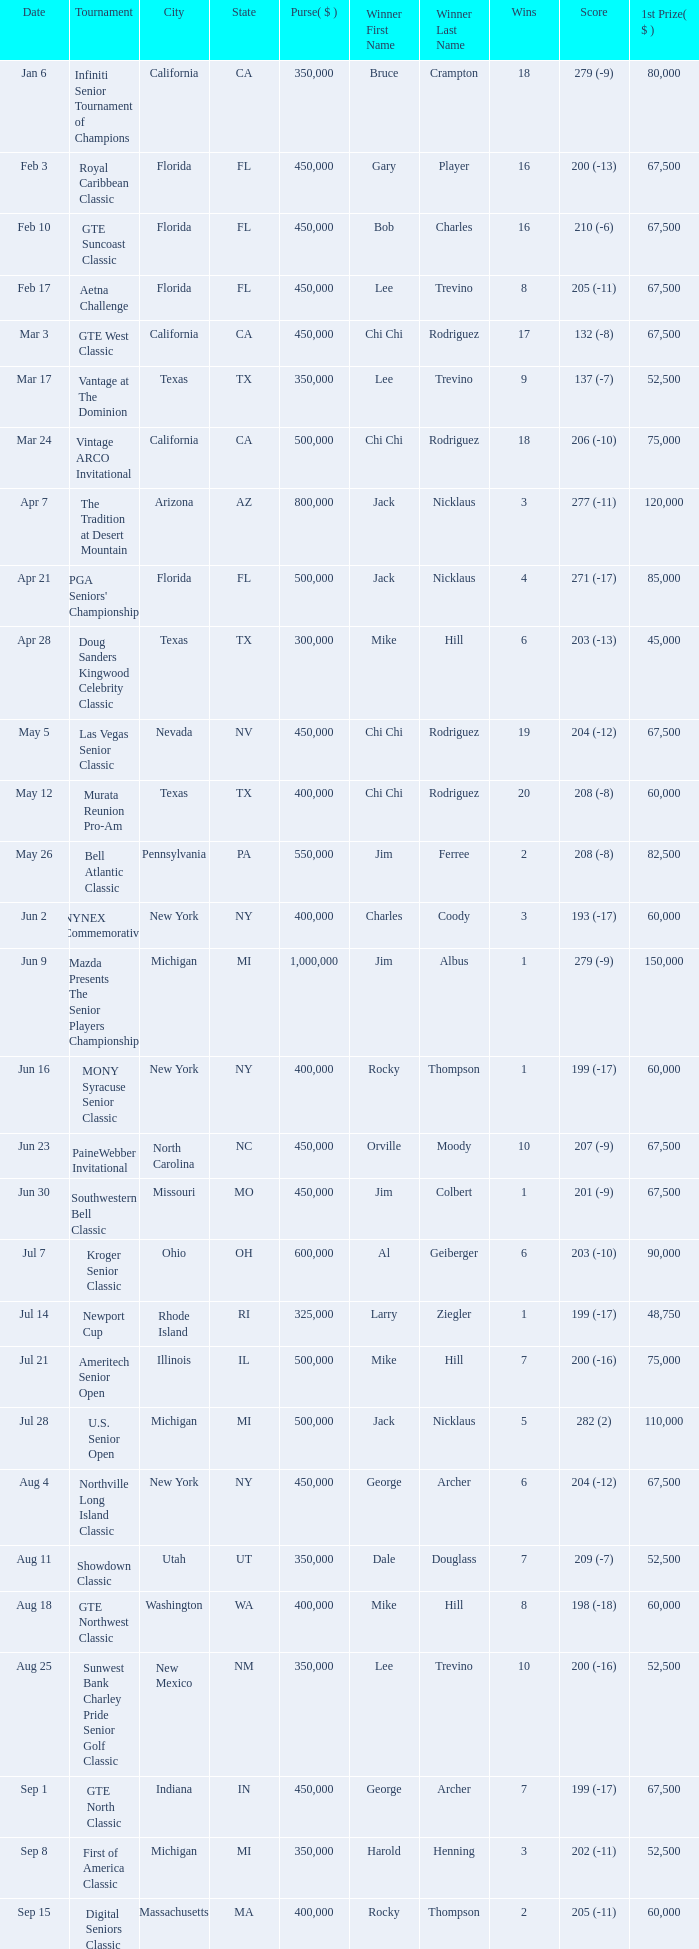What is the purse for the tournament with a winning score of 212 (-4), and a 1st prize of under $105,000? None. 